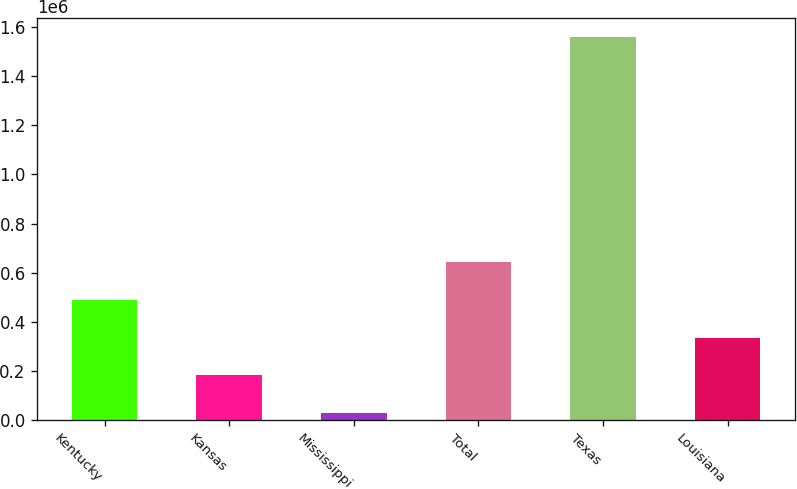<chart> <loc_0><loc_0><loc_500><loc_500><bar_chart><fcel>Kentucky<fcel>Kansas<fcel>Mississippi<fcel>Total<fcel>Texas<fcel>Louisiana<nl><fcel>489400<fcel>183800<fcel>31000<fcel>642200<fcel>1.559e+06<fcel>336600<nl></chart> 